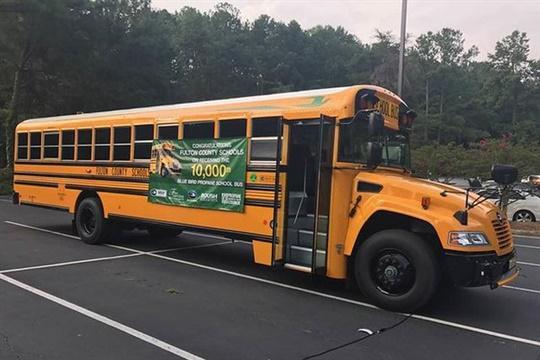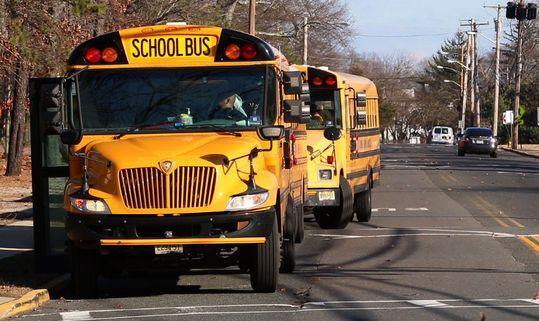The first image is the image on the left, the second image is the image on the right. Analyze the images presented: Is the assertion "People are standing outside the bus in the image on the right." valid? Answer yes or no. No. The first image is the image on the left, the second image is the image on the right. Considering the images on both sides, is "The right image shows at least one person standing on a curb by the open door of a parked yellow bus with a non-flat front." valid? Answer yes or no. No. 